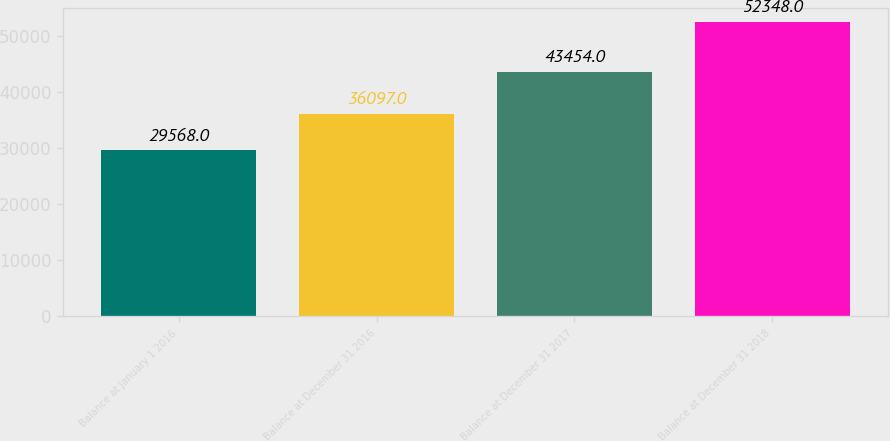Convert chart to OTSL. <chart><loc_0><loc_0><loc_500><loc_500><bar_chart><fcel>Balance at January 1 2016<fcel>Balance at December 31 2016<fcel>Balance at December 31 2017<fcel>Balance at December 31 2018<nl><fcel>29568<fcel>36097<fcel>43454<fcel>52348<nl></chart> 